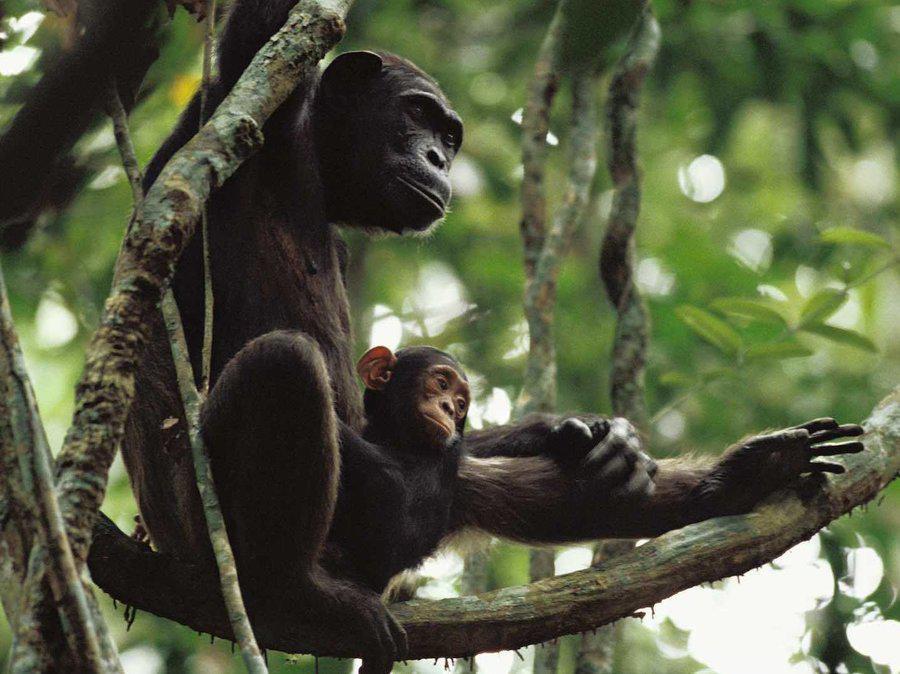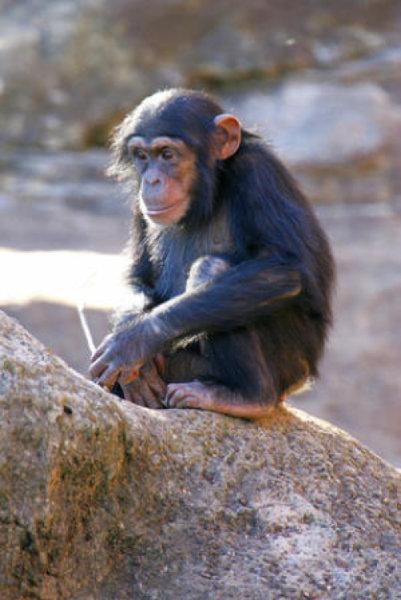The first image is the image on the left, the second image is the image on the right. Examine the images to the left and right. Is the description "The image on the right features only one chimp." accurate? Answer yes or no. Yes. 